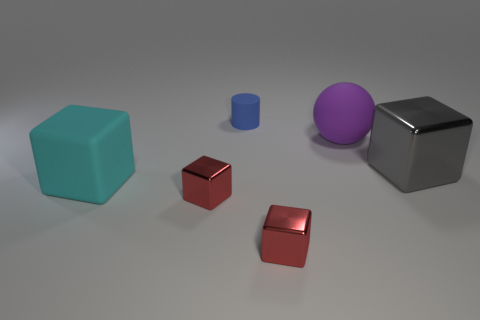Is the material of the large block on the left side of the large shiny block the same as the gray object?
Keep it short and to the point. No. The other big object that is the same shape as the large cyan thing is what color?
Provide a succinct answer. Gray. How many other things are there of the same color as the large matte ball?
Offer a terse response. 0. There is a matte object that is in front of the large gray object; does it have the same shape as the small object that is behind the large purple matte sphere?
Ensure brevity in your answer.  No. What number of balls are small red rubber things or large objects?
Give a very brief answer. 1. Are there fewer metallic cubes left of the big cyan rubber block than small gray spheres?
Provide a succinct answer. No. How many other things are made of the same material as the gray block?
Offer a terse response. 2. Does the gray metallic block have the same size as the purple matte sphere?
Provide a short and direct response. Yes. What number of things are blocks that are left of the sphere or small blue spheres?
Your response must be concise. 3. There is a large block that is on the right side of the large matte thing that is behind the cyan object; what is its material?
Provide a succinct answer. Metal. 